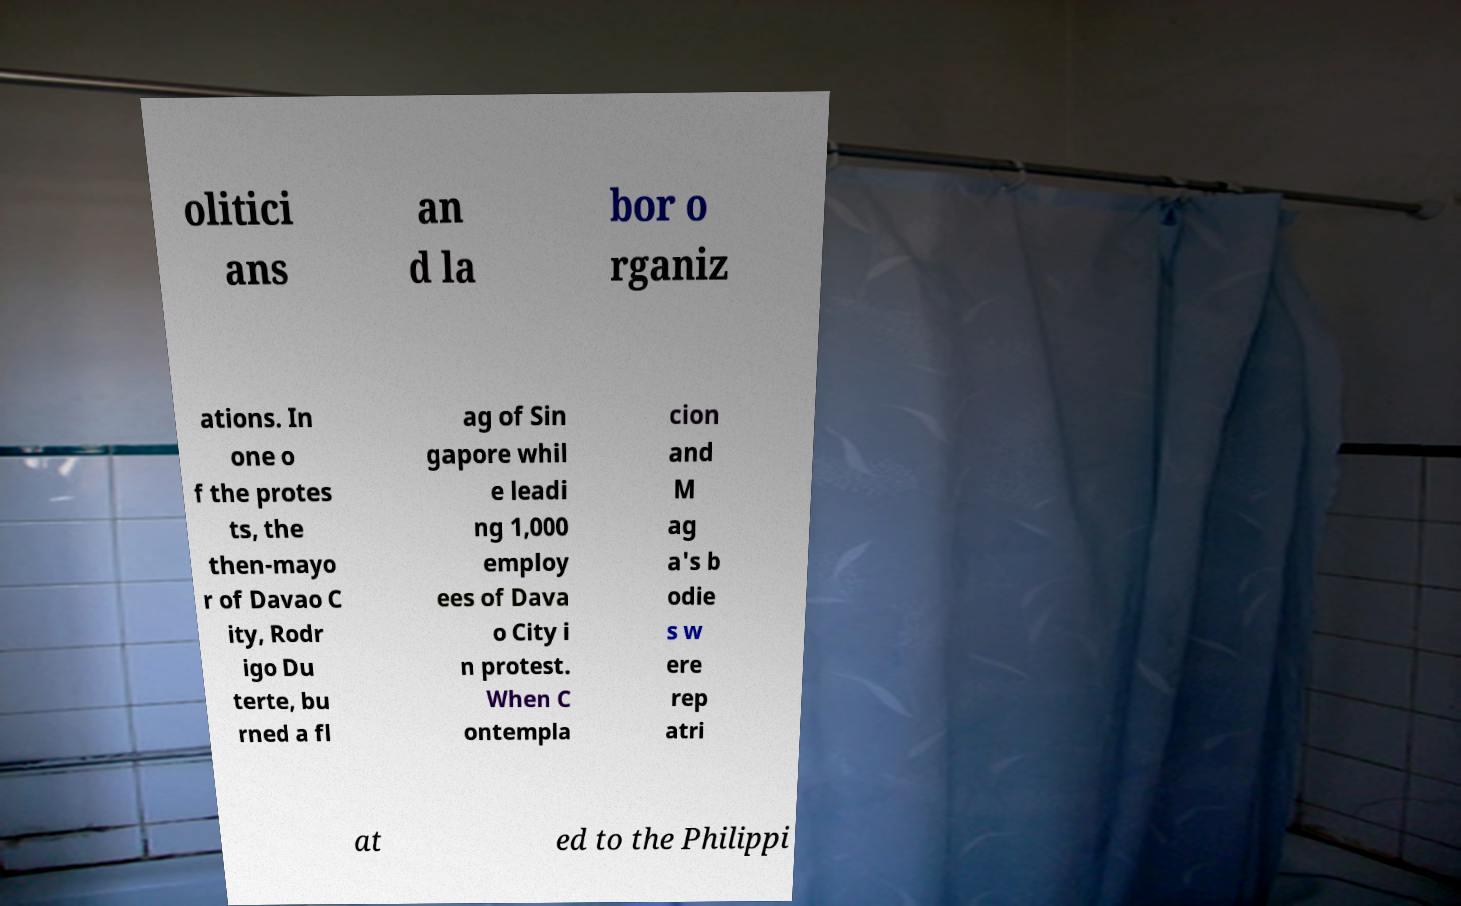Please read and relay the text visible in this image. What does it say? olitici ans an d la bor o rganiz ations. In one o f the protes ts, the then-mayo r of Davao C ity, Rodr igo Du terte, bu rned a fl ag of Sin gapore whil e leadi ng 1,000 employ ees of Dava o City i n protest. When C ontempla cion and M ag a's b odie s w ere rep atri at ed to the Philippi 